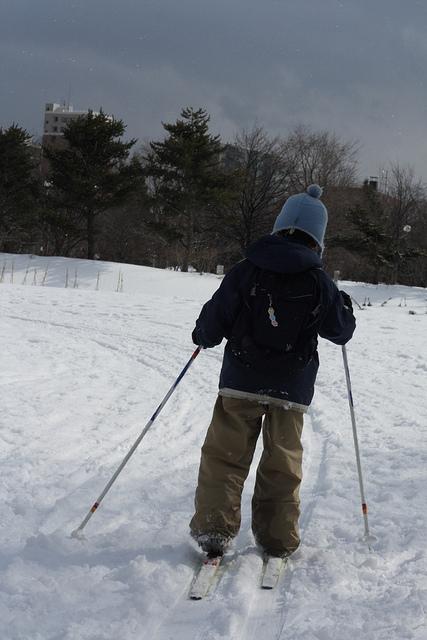Why is he wearing a coat and hat?
Answer briefly. Cold. What is in his hand?
Short answer required. Ski poles. Is this a child or an adult?
Quick response, please. Child. 